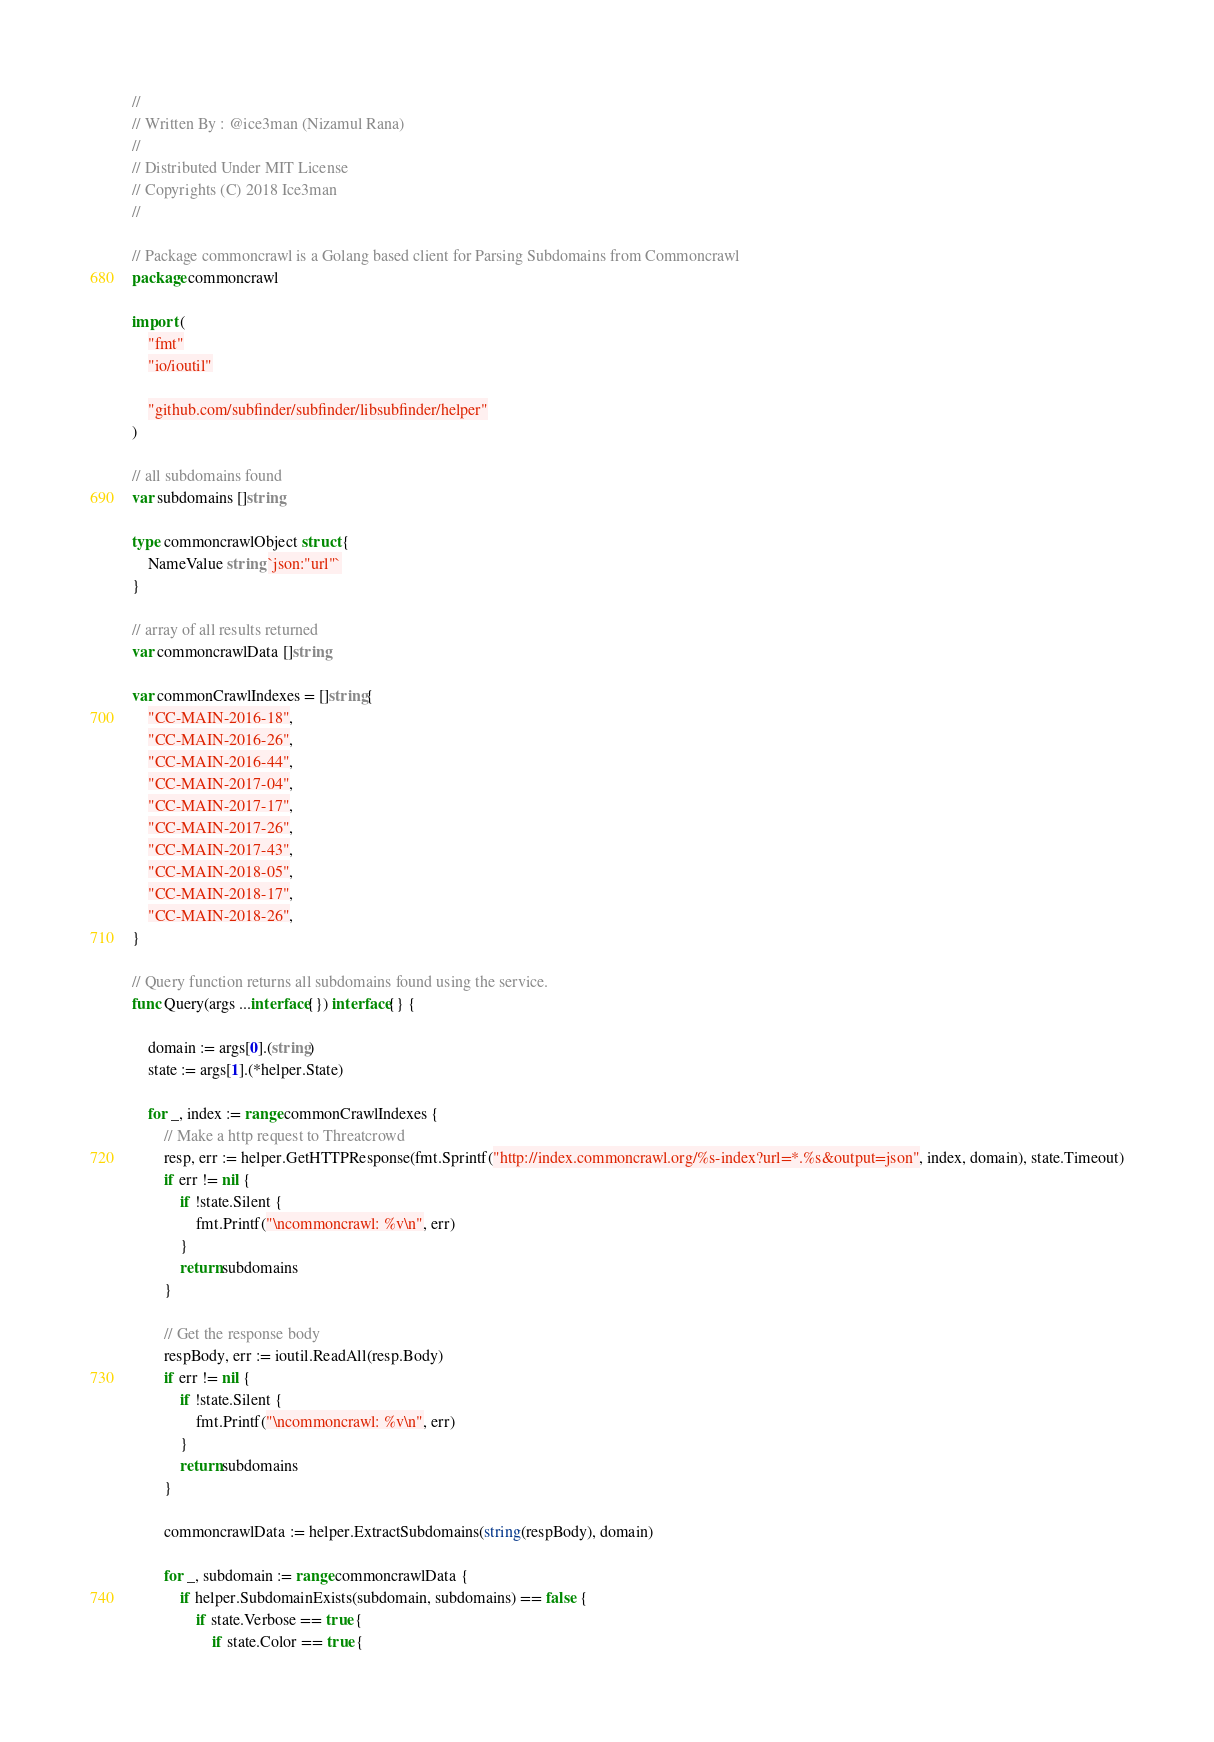<code> <loc_0><loc_0><loc_500><loc_500><_Go_>//
// Written By : @ice3man (Nizamul Rana)
//
// Distributed Under MIT License
// Copyrights (C) 2018 Ice3man
//

// Package commoncrawl is a Golang based client for Parsing Subdomains from Commoncrawl
package commoncrawl

import (
	"fmt"
	"io/ioutil"

	"github.com/subfinder/subfinder/libsubfinder/helper"
)

// all subdomains found
var subdomains []string

type commoncrawlObject struct {
	NameValue string `json:"url"`
}

// array of all results returned
var commoncrawlData []string

var commonCrawlIndexes = []string{
	"CC-MAIN-2016-18",
	"CC-MAIN-2016-26",
	"CC-MAIN-2016-44",
	"CC-MAIN-2017-04",
	"CC-MAIN-2017-17",
	"CC-MAIN-2017-26",
	"CC-MAIN-2017-43",
	"CC-MAIN-2018-05",
	"CC-MAIN-2018-17",
	"CC-MAIN-2018-26",
}

// Query function returns all subdomains found using the service.
func Query(args ...interface{}) interface{} {

	domain := args[0].(string)
	state := args[1].(*helper.State)

	for _, index := range commonCrawlIndexes {
		// Make a http request to Threatcrowd
		resp, err := helper.GetHTTPResponse(fmt.Sprintf("http://index.commoncrawl.org/%s-index?url=*.%s&output=json", index, domain), state.Timeout)
		if err != nil {
			if !state.Silent {
				fmt.Printf("\ncommoncrawl: %v\n", err)
			}
			return subdomains
		}

		// Get the response body
		respBody, err := ioutil.ReadAll(resp.Body)
		if err != nil {
			if !state.Silent {
				fmt.Printf("\ncommoncrawl: %v\n", err)
			}
			return subdomains
		}

		commoncrawlData := helper.ExtractSubdomains(string(respBody), domain)

		for _, subdomain := range commoncrawlData {
			if helper.SubdomainExists(subdomain, subdomains) == false {
				if state.Verbose == true {
					if state.Color == true {</code> 